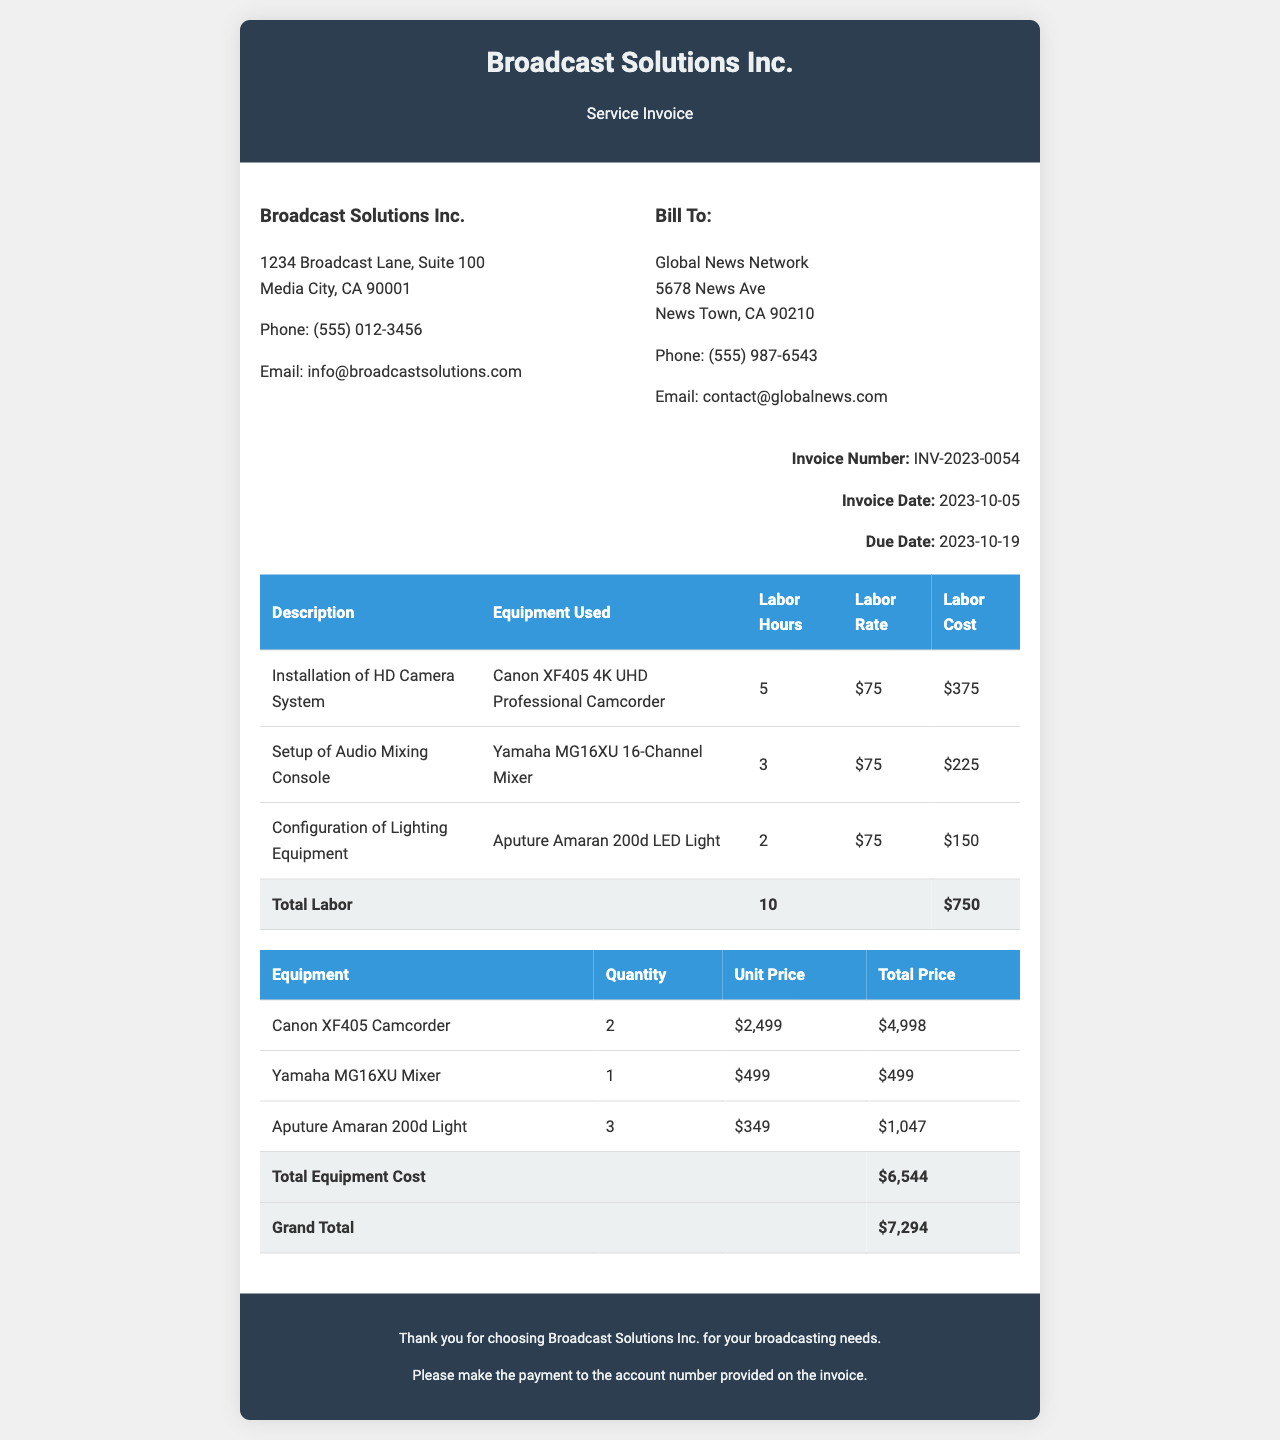What is the invoice number? The invoice number is explicitly stated in the invoice details section.
Answer: INV-2023-0054 What is the due date for payment? The due date is mentioned near the invoice date in the invoice details.
Answer: 2023-10-19 Who is the customer for this invoice? The customer information is provided in the "Bill To" section of the document.
Answer: Global News Network What is the total labor cost? The total labor cost is calculated and displayed in the total row for labor costs in the services table.
Answer: $750 How many units of the Canon XF405 Camcorder were used? The quantity of the Canon XF405 Camcorder is found in the equipment section of the invoice.
Answer: 2 What is the labor rate per hour? The labor rate is specified in the labor costs table.
Answer: $75 What is the grand total of the invoice? The grand total is provided in the total row at the end of the equipment costs section.
Answer: $7,294 Which equipment had the highest unit price? The unit prices are listed in the equipment cost section, and the one with the highest price needs to be identified.
Answer: Canon XF405 Camcorder How many labor hours were used in total? The total labor hours are summed up in the services table under the total row for labor.
Answer: 10 